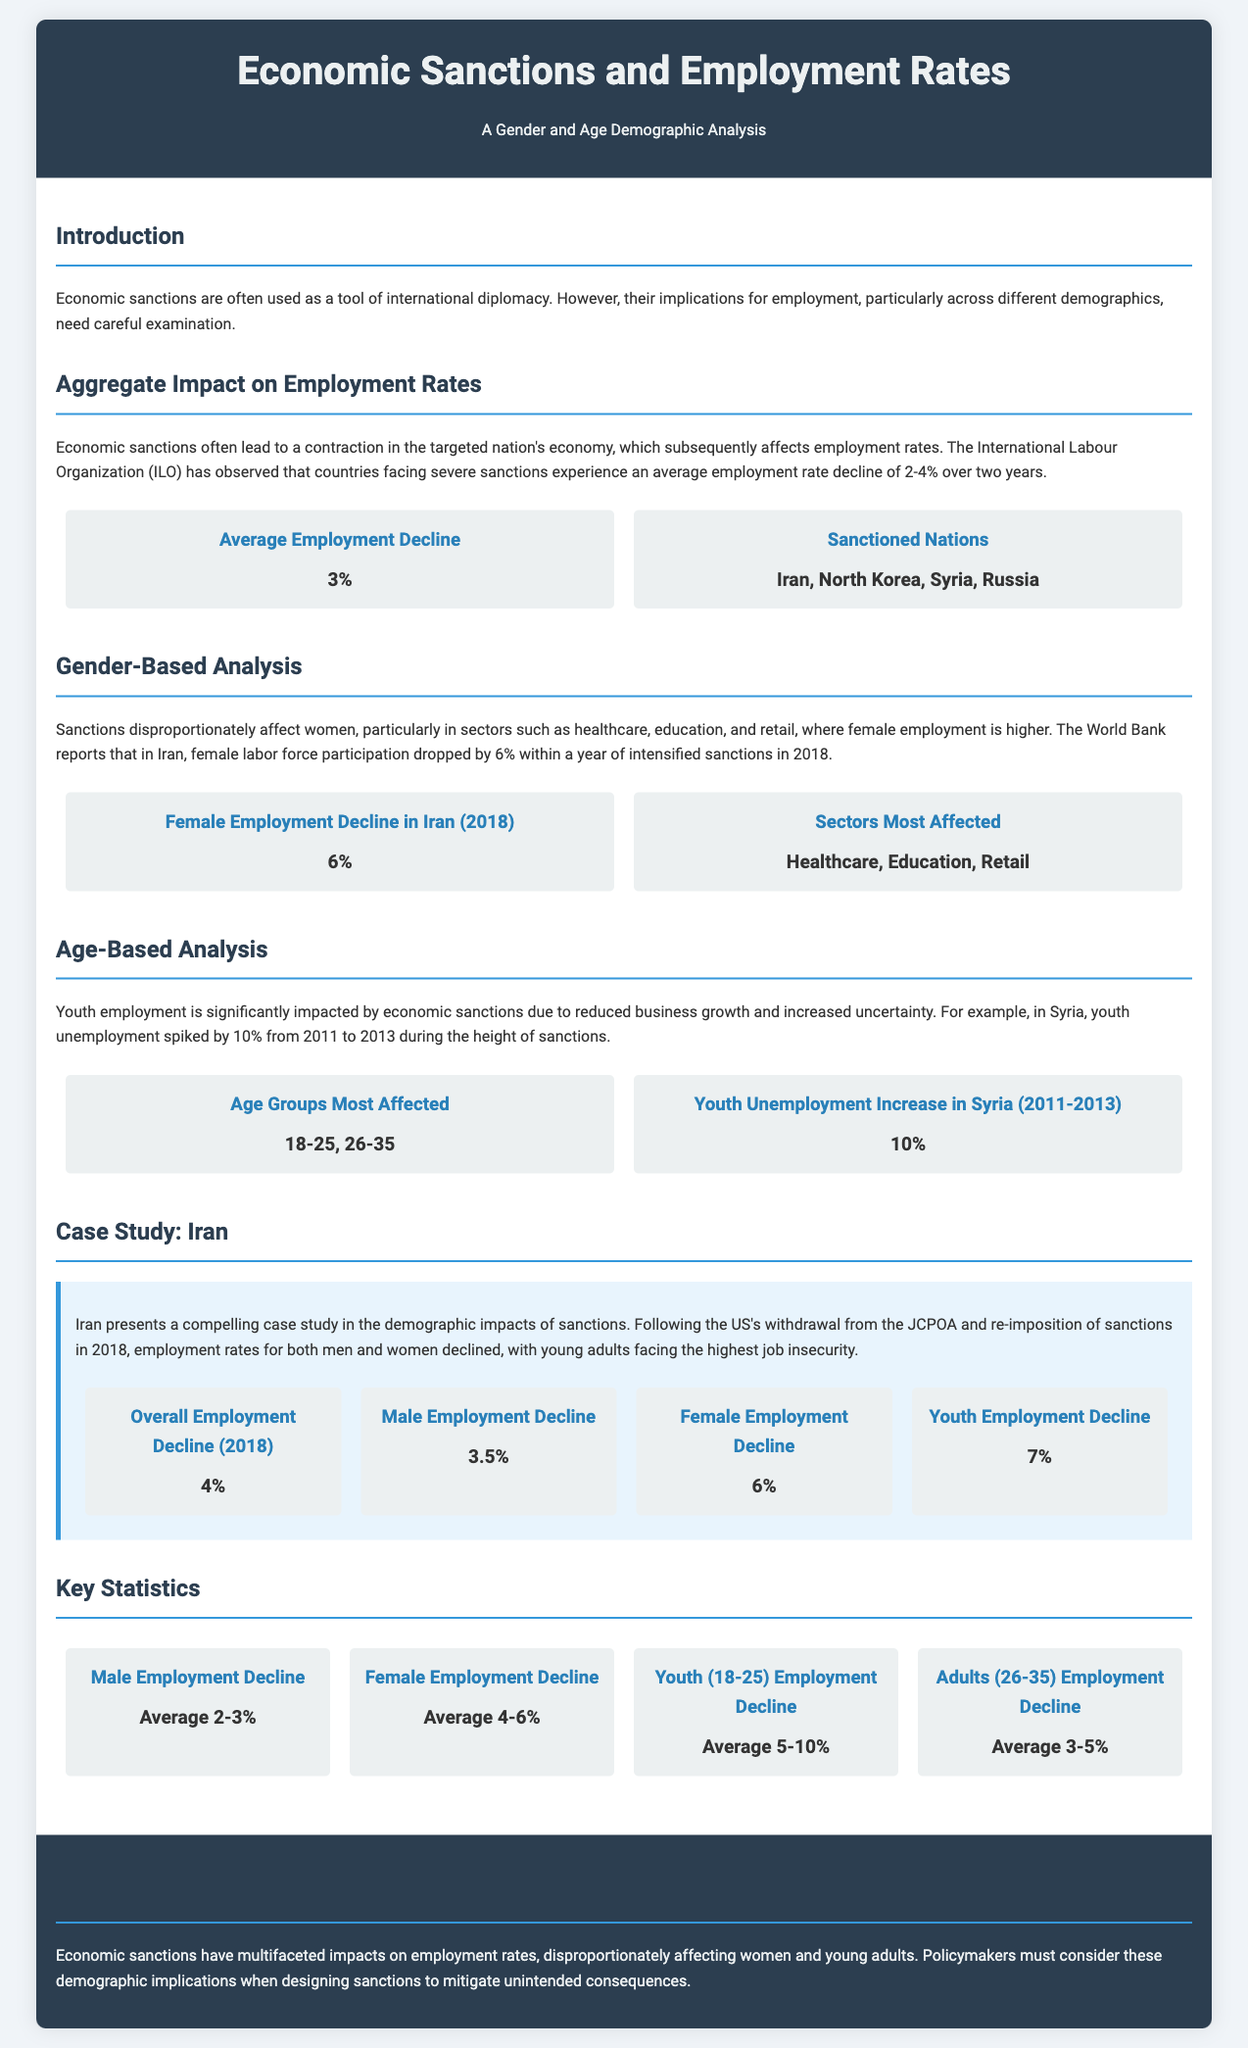What is the average employment rate decline due to economic sanctions? The document states that the average employment rate decline is between 2-4% over two years.
Answer: 3% Which countries are listed as sanctioned nations? The document lists Iran, North Korea, Syria, and Russia as sanctioned nations.
Answer: Iran, North Korea, Syria, Russia What sector sees the highest female employment affected by sanctions? Healthcare, education, and retail are identified as sectors most affected by sanctions for female employment.
Answer: Healthcare, Education, Retail What percentage did female labor force participation drop in Iran within a year of intensified sanctions? The document notes that female labor force participation in Iran dropped by 6% within a year of intensified sanctions in 2018.
Answer: 6% Which age groups are most affected by youth unemployment due to sanctions? The document highlights that the age groups 18-25 and 26-35 are most affected by youth unemployment.
Answer: 18-25, 26-35 How much did youth unemployment increase in Syria from 2011 to 2013? The document states that youth unemployment in Syria spiked by 10% during this period.
Answer: 10% What was the overall employment decline in Iran in 2018? The overall employment decline in Iran due to sanctions in 2018 was reported to be 4%.
Answer: 4% What was the percentage decline in female employment in Iran due to sanctions? The document indicates that the decline in female employment in Iran was 6%.
Answer: 6% What does the document identify as a key conclusion regarding economic sanctions? The key conclusion is that economic sanctions have multifaceted impacts, disproportionately affecting women and young adults.
Answer: Disproportionately affecting women and young adults 